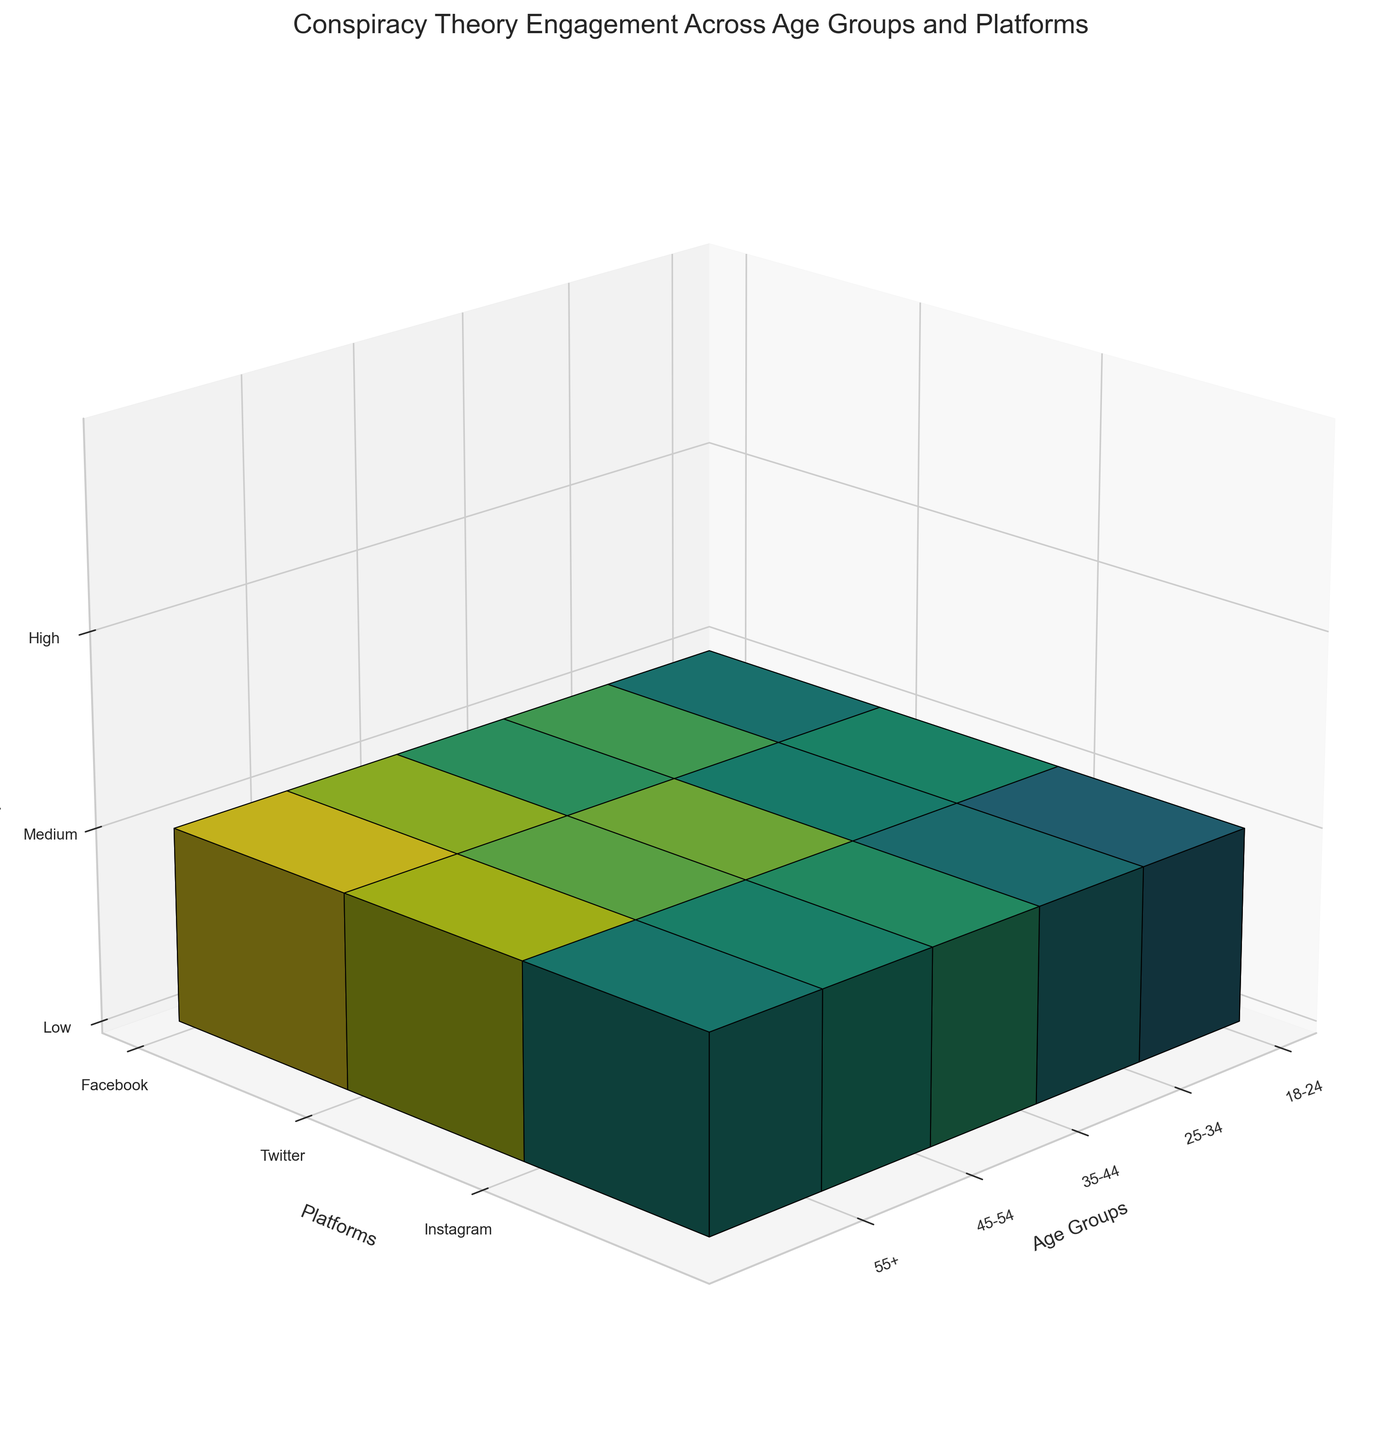What platforms are visualized on the y-axis? The y-axis represents different social media platforms. From the labels, we can see that the platforms visualized are Facebook, Twitter, and Instagram.
Answer: Facebook, Twitter, Instagram What age groups show the highest engagement score? To find this, we need to look at which age groups have the brightest (or most colorful) voxels. The age groups are on the x-axis. The '55+' group shows the highest engagement score with the brightest colors for conspiracy theories on various platforms.
Answer: 55+ Which age group has the lowest engagement score on Instagram? Identify the age group for Instagram with the least intense color. By observing the z-axis where 'Engagement Level' is labeled, the 18-24 group shows the lowest engagement score on Instagram.
Answer: 18-24 How does engagement differ between Facebook and Twitter for the 45-54 age group? Check the voxels for the 45-54 age group specifically. Compare the color intensity (indicating engagement score) between Facebook and Twitter. Facebook has a noticeably higher intensity voxel compared to Twitter for this age group.
Answer: Facebook shows higher engagement What conspiracy theory has the highest engagement score on Twitter? While the specific conspiracy theories aren't labeled on the figure itself, by interpreting the color intensities and knowing that Twitter has a high engagement for the age group 35-44, it implies that Vaccine Microchips conspiracy theory has the highest engagement score.
Answer: Vaccine Microchips Which social media platform has consistent engagement across all age groups? Evaluate the voxels' colors across age groups for each platform. Instagram shows relatively moderate and consistent colors across all age groups.
Answer: Instagram For the '18-24' age group, which platform has the highest engagement? Focus on the voxels along the x-axis for '18-24' and compare them by their color intensity. Twitter shows the most intense color, indicating the highest engagement.
Answer: Twitter Compare the engagement in the '25-34' age group on Instagram versus Twitter. Look at the voxels for the '25-34' age group (x-axis) and compare Instagram and Twitter's engagement scores by their color intensities. Engagement is higher on Twitter based on color intensity.
Answer: Higher on Twitter What can be inferred about the engagement trends in people older than 54 on Facebook? Observe the color intensity for the '55+' age group on Facebook. The high-intensity color suggests that people older than 54 have very high engagement with conspiracy theories on Facebook.
Answer: Very high engagement Between '35-44' and '45-54', which age group shows higher engagement on Instagram? Check the color intensities of the voxels along the x-axis for '35-44' and '45-54' specifically for Instagram. The '35-44' group has a brighter color, indicating higher engagement.
Answer: 35-44 